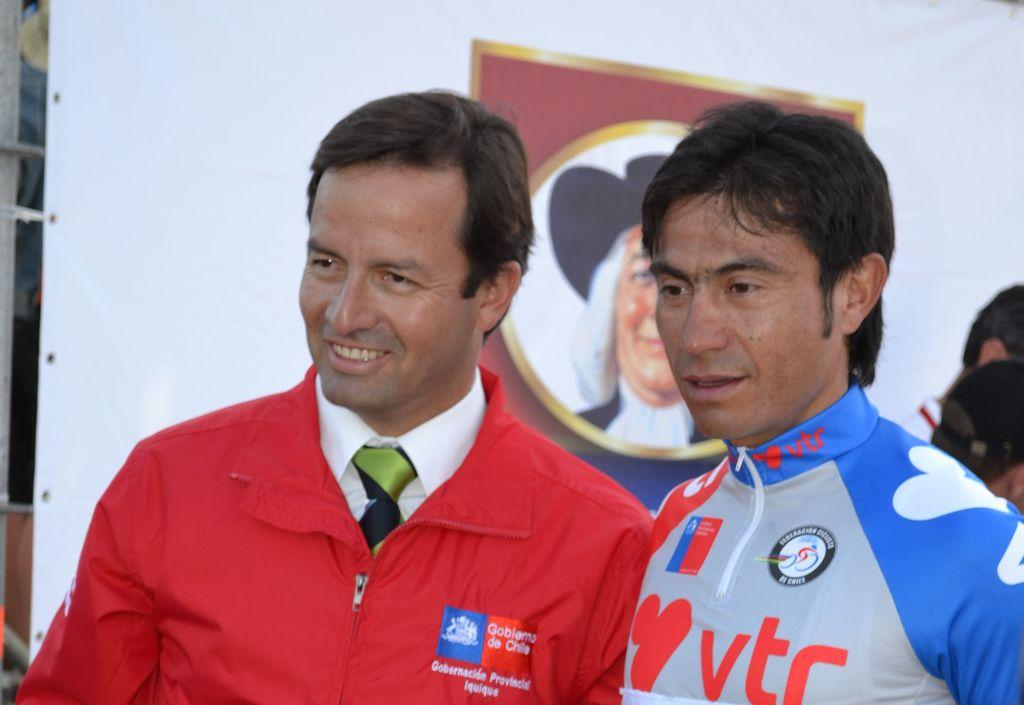<image>
Share a concise interpretation of the image provided. Man wearing a shirt that says VTC on it. 